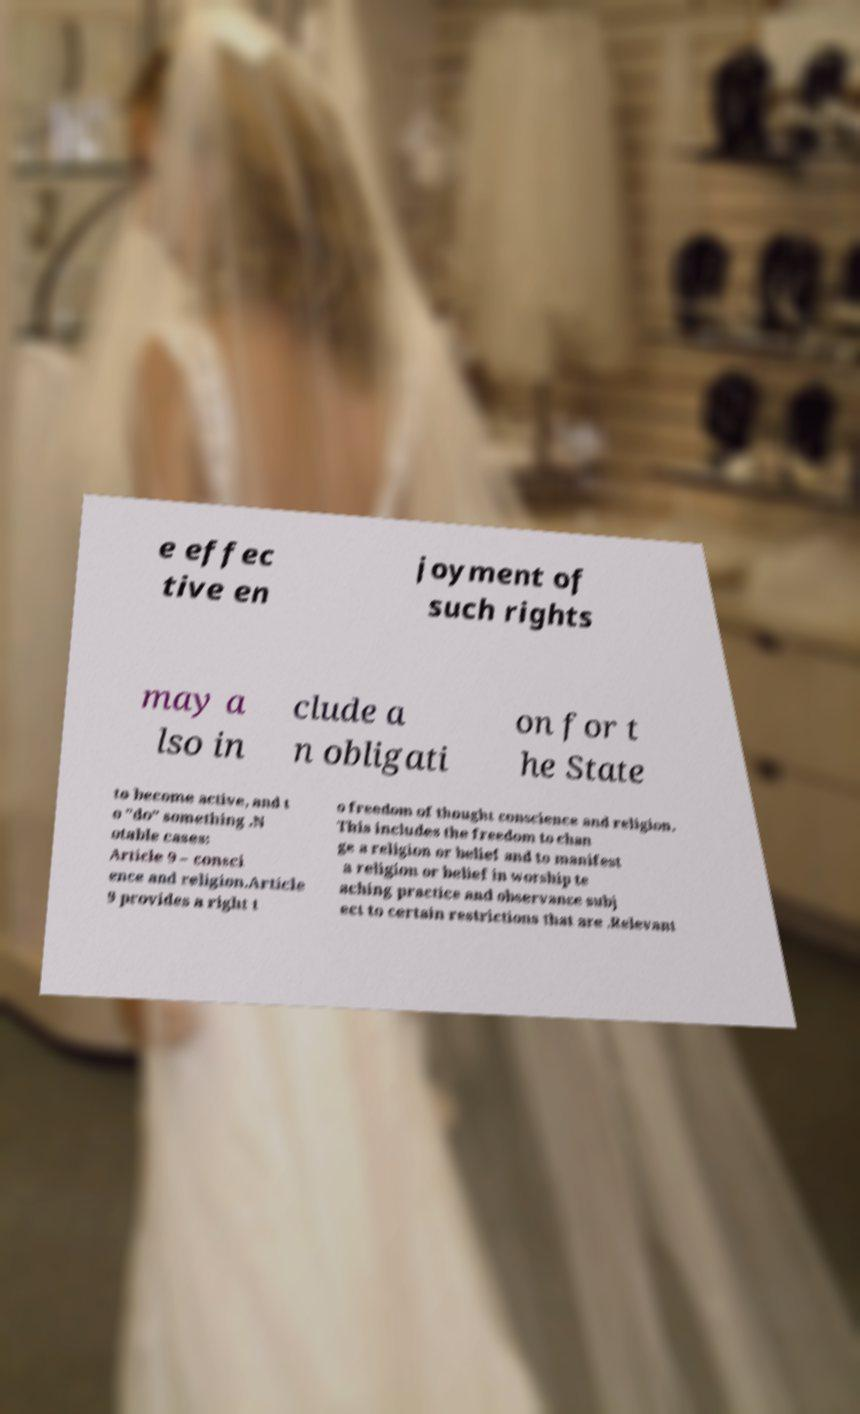What messages or text are displayed in this image? I need them in a readable, typed format. e effec tive en joyment of such rights may a lso in clude a n obligati on for t he State to become active, and t o "do" something .N otable cases: Article 9 – consci ence and religion.Article 9 provides a right t o freedom of thought conscience and religion. This includes the freedom to chan ge a religion or belief and to manifest a religion or belief in worship te aching practice and observance subj ect to certain restrictions that are .Relevant 